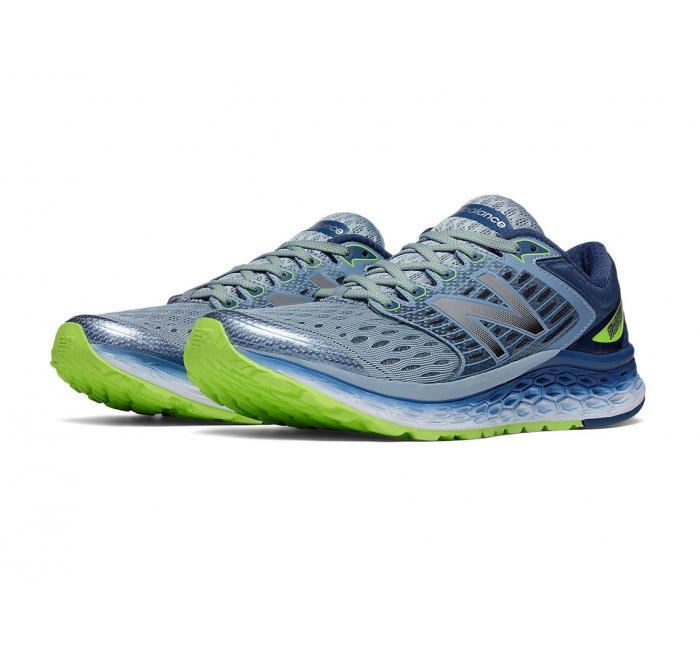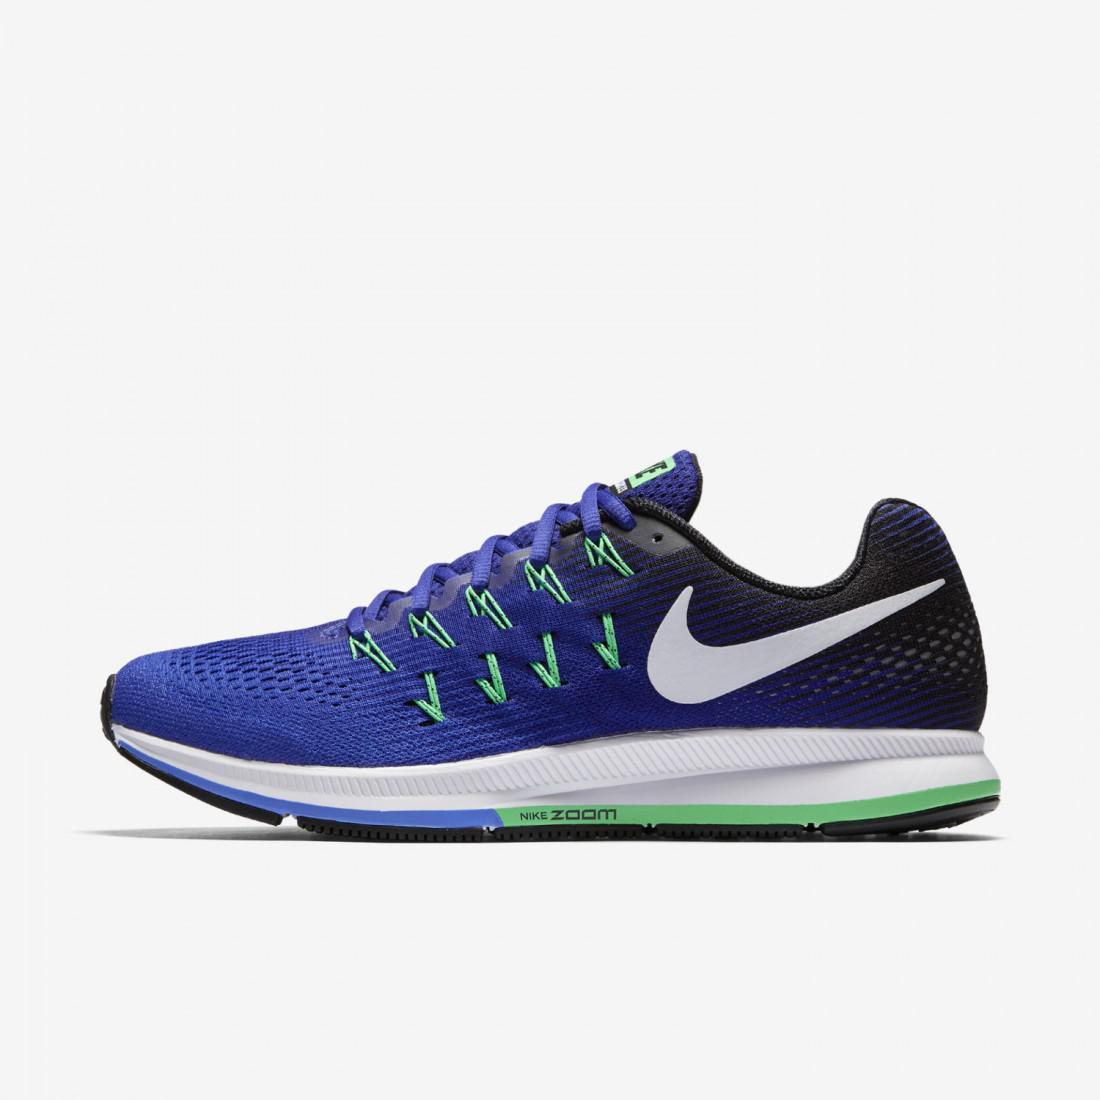The first image is the image on the left, the second image is the image on the right. Evaluate the accuracy of this statement regarding the images: "There are more than two shoes pictured.". Is it true? Answer yes or no. Yes. The first image is the image on the left, the second image is the image on the right. Assess this claim about the two images: "The left image contains a matched pair of unworn sneakers, and the right image features a sneaker that shares some of the color of the lefthand sneaker.". Correct or not? Answer yes or no. Yes. 